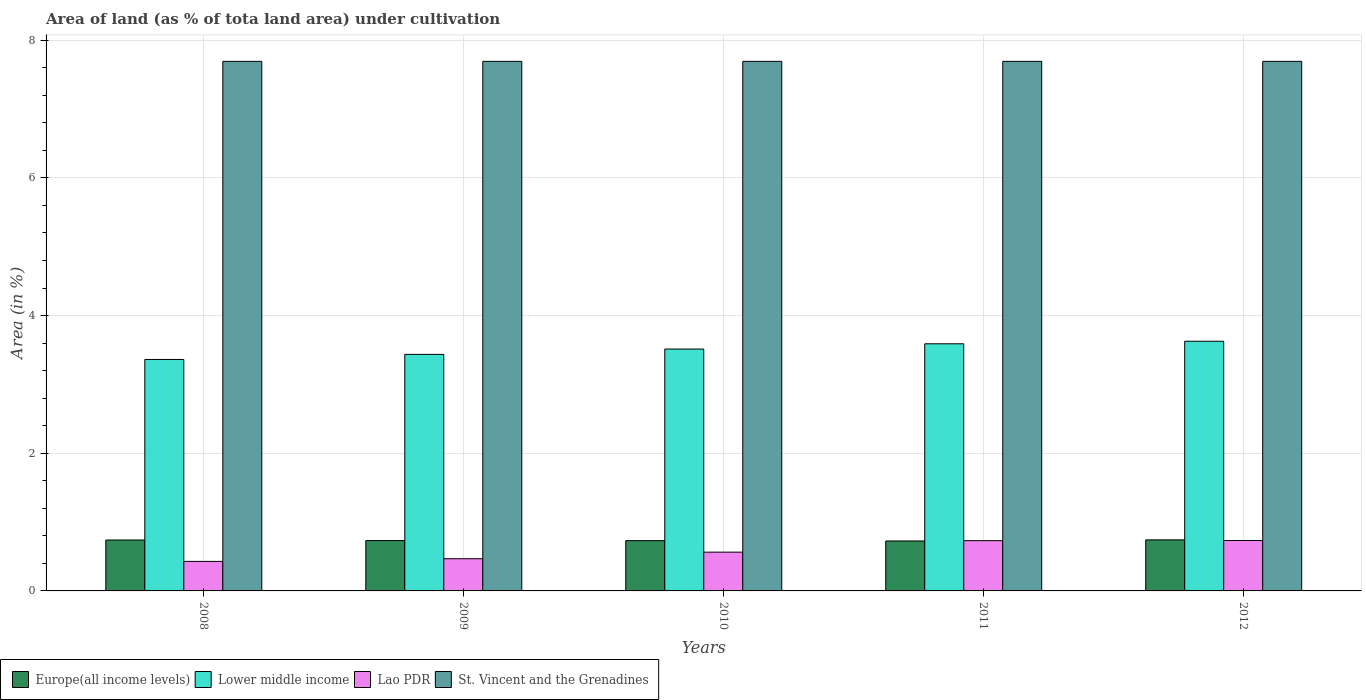How many different coloured bars are there?
Ensure brevity in your answer.  4. Are the number of bars per tick equal to the number of legend labels?
Your response must be concise. Yes. What is the label of the 2nd group of bars from the left?
Provide a short and direct response. 2009. In how many cases, is the number of bars for a given year not equal to the number of legend labels?
Your response must be concise. 0. What is the percentage of land under cultivation in Lower middle income in 2012?
Give a very brief answer. 3.63. Across all years, what is the maximum percentage of land under cultivation in Europe(all income levels)?
Give a very brief answer. 0.74. Across all years, what is the minimum percentage of land under cultivation in Lower middle income?
Provide a succinct answer. 3.36. In which year was the percentage of land under cultivation in Lower middle income minimum?
Offer a terse response. 2008. What is the total percentage of land under cultivation in St. Vincent and the Grenadines in the graph?
Offer a terse response. 38.46. What is the difference between the percentage of land under cultivation in St. Vincent and the Grenadines in 2009 and that in 2010?
Give a very brief answer. 0. What is the difference between the percentage of land under cultivation in Lower middle income in 2011 and the percentage of land under cultivation in St. Vincent and the Grenadines in 2010?
Your response must be concise. -4.1. What is the average percentage of land under cultivation in Lower middle income per year?
Offer a terse response. 3.51. In the year 2012, what is the difference between the percentage of land under cultivation in Lao PDR and percentage of land under cultivation in Lower middle income?
Make the answer very short. -2.89. In how many years, is the percentage of land under cultivation in St. Vincent and the Grenadines greater than 6.4 %?
Ensure brevity in your answer.  5. What is the ratio of the percentage of land under cultivation in Lao PDR in 2008 to that in 2009?
Keep it short and to the point. 0.92. Is the percentage of land under cultivation in St. Vincent and the Grenadines in 2009 less than that in 2012?
Provide a short and direct response. No. What is the difference between the highest and the second highest percentage of land under cultivation in Europe(all income levels)?
Your answer should be compact. 0. What is the difference between the highest and the lowest percentage of land under cultivation in Lower middle income?
Provide a succinct answer. 0.26. Is the sum of the percentage of land under cultivation in Europe(all income levels) in 2008 and 2009 greater than the maximum percentage of land under cultivation in Lower middle income across all years?
Your answer should be very brief. No. What does the 3rd bar from the left in 2008 represents?
Ensure brevity in your answer.  Lao PDR. What does the 1st bar from the right in 2009 represents?
Make the answer very short. St. Vincent and the Grenadines. Is it the case that in every year, the sum of the percentage of land under cultivation in St. Vincent and the Grenadines and percentage of land under cultivation in Lower middle income is greater than the percentage of land under cultivation in Europe(all income levels)?
Your answer should be very brief. Yes. Are all the bars in the graph horizontal?
Make the answer very short. No. What is the difference between two consecutive major ticks on the Y-axis?
Provide a short and direct response. 2. Does the graph contain grids?
Keep it short and to the point. Yes. Where does the legend appear in the graph?
Keep it short and to the point. Bottom left. How many legend labels are there?
Provide a short and direct response. 4. How are the legend labels stacked?
Offer a terse response. Horizontal. What is the title of the graph?
Make the answer very short. Area of land (as % of tota land area) under cultivation. Does "Channel Islands" appear as one of the legend labels in the graph?
Provide a short and direct response. No. What is the label or title of the Y-axis?
Offer a terse response. Area (in %). What is the Area (in %) in Europe(all income levels) in 2008?
Give a very brief answer. 0.74. What is the Area (in %) in Lower middle income in 2008?
Provide a short and direct response. 3.36. What is the Area (in %) in Lao PDR in 2008?
Offer a terse response. 0.43. What is the Area (in %) of St. Vincent and the Grenadines in 2008?
Provide a short and direct response. 7.69. What is the Area (in %) of Europe(all income levels) in 2009?
Keep it short and to the point. 0.73. What is the Area (in %) in Lower middle income in 2009?
Keep it short and to the point. 3.44. What is the Area (in %) of Lao PDR in 2009?
Make the answer very short. 0.47. What is the Area (in %) of St. Vincent and the Grenadines in 2009?
Keep it short and to the point. 7.69. What is the Area (in %) in Europe(all income levels) in 2010?
Offer a very short reply. 0.73. What is the Area (in %) of Lower middle income in 2010?
Your response must be concise. 3.51. What is the Area (in %) of Lao PDR in 2010?
Give a very brief answer. 0.56. What is the Area (in %) in St. Vincent and the Grenadines in 2010?
Ensure brevity in your answer.  7.69. What is the Area (in %) in Europe(all income levels) in 2011?
Offer a terse response. 0.73. What is the Area (in %) of Lower middle income in 2011?
Your answer should be compact. 3.59. What is the Area (in %) in Lao PDR in 2011?
Offer a terse response. 0.73. What is the Area (in %) of St. Vincent and the Grenadines in 2011?
Your answer should be compact. 7.69. What is the Area (in %) in Europe(all income levels) in 2012?
Keep it short and to the point. 0.74. What is the Area (in %) of Lower middle income in 2012?
Keep it short and to the point. 3.63. What is the Area (in %) of Lao PDR in 2012?
Your response must be concise. 0.73. What is the Area (in %) in St. Vincent and the Grenadines in 2012?
Your response must be concise. 7.69. Across all years, what is the maximum Area (in %) in Europe(all income levels)?
Offer a very short reply. 0.74. Across all years, what is the maximum Area (in %) of Lower middle income?
Your response must be concise. 3.63. Across all years, what is the maximum Area (in %) of Lao PDR?
Offer a terse response. 0.73. Across all years, what is the maximum Area (in %) in St. Vincent and the Grenadines?
Give a very brief answer. 7.69. Across all years, what is the minimum Area (in %) in Europe(all income levels)?
Make the answer very short. 0.73. Across all years, what is the minimum Area (in %) of Lower middle income?
Keep it short and to the point. 3.36. Across all years, what is the minimum Area (in %) of Lao PDR?
Offer a terse response. 0.43. Across all years, what is the minimum Area (in %) of St. Vincent and the Grenadines?
Your answer should be compact. 7.69. What is the total Area (in %) in Europe(all income levels) in the graph?
Your response must be concise. 3.67. What is the total Area (in %) in Lower middle income in the graph?
Keep it short and to the point. 17.53. What is the total Area (in %) in Lao PDR in the graph?
Your response must be concise. 2.92. What is the total Area (in %) in St. Vincent and the Grenadines in the graph?
Provide a short and direct response. 38.46. What is the difference between the Area (in %) of Europe(all income levels) in 2008 and that in 2009?
Offer a terse response. 0.01. What is the difference between the Area (in %) in Lower middle income in 2008 and that in 2009?
Give a very brief answer. -0.07. What is the difference between the Area (in %) of Lao PDR in 2008 and that in 2009?
Give a very brief answer. -0.04. What is the difference between the Area (in %) of St. Vincent and the Grenadines in 2008 and that in 2009?
Your answer should be very brief. 0. What is the difference between the Area (in %) in Europe(all income levels) in 2008 and that in 2010?
Your answer should be very brief. 0.01. What is the difference between the Area (in %) in Lower middle income in 2008 and that in 2010?
Your answer should be very brief. -0.15. What is the difference between the Area (in %) in Lao PDR in 2008 and that in 2010?
Your response must be concise. -0.13. What is the difference between the Area (in %) in Europe(all income levels) in 2008 and that in 2011?
Ensure brevity in your answer.  0.01. What is the difference between the Area (in %) of Lower middle income in 2008 and that in 2011?
Give a very brief answer. -0.23. What is the difference between the Area (in %) of Lao PDR in 2008 and that in 2011?
Offer a very short reply. -0.3. What is the difference between the Area (in %) in St. Vincent and the Grenadines in 2008 and that in 2011?
Offer a terse response. 0. What is the difference between the Area (in %) of Europe(all income levels) in 2008 and that in 2012?
Ensure brevity in your answer.  -0. What is the difference between the Area (in %) of Lower middle income in 2008 and that in 2012?
Your response must be concise. -0.26. What is the difference between the Area (in %) of Lao PDR in 2008 and that in 2012?
Offer a very short reply. -0.3. What is the difference between the Area (in %) of Europe(all income levels) in 2009 and that in 2010?
Make the answer very short. 0. What is the difference between the Area (in %) of Lower middle income in 2009 and that in 2010?
Give a very brief answer. -0.08. What is the difference between the Area (in %) of Lao PDR in 2009 and that in 2010?
Offer a terse response. -0.1. What is the difference between the Area (in %) of St. Vincent and the Grenadines in 2009 and that in 2010?
Offer a terse response. 0. What is the difference between the Area (in %) of Europe(all income levels) in 2009 and that in 2011?
Your response must be concise. 0.01. What is the difference between the Area (in %) of Lower middle income in 2009 and that in 2011?
Provide a succinct answer. -0.15. What is the difference between the Area (in %) in Lao PDR in 2009 and that in 2011?
Offer a terse response. -0.26. What is the difference between the Area (in %) in Europe(all income levels) in 2009 and that in 2012?
Your response must be concise. -0.01. What is the difference between the Area (in %) in Lower middle income in 2009 and that in 2012?
Your answer should be very brief. -0.19. What is the difference between the Area (in %) in Lao PDR in 2009 and that in 2012?
Give a very brief answer. -0.26. What is the difference between the Area (in %) in St. Vincent and the Grenadines in 2009 and that in 2012?
Provide a succinct answer. 0. What is the difference between the Area (in %) of Europe(all income levels) in 2010 and that in 2011?
Offer a very short reply. 0. What is the difference between the Area (in %) of Lower middle income in 2010 and that in 2011?
Give a very brief answer. -0.08. What is the difference between the Area (in %) of Lao PDR in 2010 and that in 2011?
Keep it short and to the point. -0.17. What is the difference between the Area (in %) of Europe(all income levels) in 2010 and that in 2012?
Offer a very short reply. -0.01. What is the difference between the Area (in %) in Lower middle income in 2010 and that in 2012?
Keep it short and to the point. -0.11. What is the difference between the Area (in %) of Lao PDR in 2010 and that in 2012?
Your response must be concise. -0.17. What is the difference between the Area (in %) in Europe(all income levels) in 2011 and that in 2012?
Provide a succinct answer. -0.02. What is the difference between the Area (in %) of Lower middle income in 2011 and that in 2012?
Provide a short and direct response. -0.04. What is the difference between the Area (in %) in Lao PDR in 2011 and that in 2012?
Offer a very short reply. -0. What is the difference between the Area (in %) in Europe(all income levels) in 2008 and the Area (in %) in Lower middle income in 2009?
Make the answer very short. -2.7. What is the difference between the Area (in %) in Europe(all income levels) in 2008 and the Area (in %) in Lao PDR in 2009?
Provide a short and direct response. 0.27. What is the difference between the Area (in %) in Europe(all income levels) in 2008 and the Area (in %) in St. Vincent and the Grenadines in 2009?
Provide a succinct answer. -6.95. What is the difference between the Area (in %) of Lower middle income in 2008 and the Area (in %) of Lao PDR in 2009?
Ensure brevity in your answer.  2.89. What is the difference between the Area (in %) of Lower middle income in 2008 and the Area (in %) of St. Vincent and the Grenadines in 2009?
Provide a short and direct response. -4.33. What is the difference between the Area (in %) in Lao PDR in 2008 and the Area (in %) in St. Vincent and the Grenadines in 2009?
Make the answer very short. -7.26. What is the difference between the Area (in %) of Europe(all income levels) in 2008 and the Area (in %) of Lower middle income in 2010?
Your answer should be compact. -2.77. What is the difference between the Area (in %) of Europe(all income levels) in 2008 and the Area (in %) of Lao PDR in 2010?
Offer a terse response. 0.18. What is the difference between the Area (in %) of Europe(all income levels) in 2008 and the Area (in %) of St. Vincent and the Grenadines in 2010?
Your response must be concise. -6.95. What is the difference between the Area (in %) of Lower middle income in 2008 and the Area (in %) of Lao PDR in 2010?
Ensure brevity in your answer.  2.8. What is the difference between the Area (in %) of Lower middle income in 2008 and the Area (in %) of St. Vincent and the Grenadines in 2010?
Your answer should be compact. -4.33. What is the difference between the Area (in %) in Lao PDR in 2008 and the Area (in %) in St. Vincent and the Grenadines in 2010?
Your response must be concise. -7.26. What is the difference between the Area (in %) of Europe(all income levels) in 2008 and the Area (in %) of Lower middle income in 2011?
Make the answer very short. -2.85. What is the difference between the Area (in %) in Europe(all income levels) in 2008 and the Area (in %) in Lao PDR in 2011?
Make the answer very short. 0.01. What is the difference between the Area (in %) in Europe(all income levels) in 2008 and the Area (in %) in St. Vincent and the Grenadines in 2011?
Ensure brevity in your answer.  -6.95. What is the difference between the Area (in %) of Lower middle income in 2008 and the Area (in %) of Lao PDR in 2011?
Your response must be concise. 2.63. What is the difference between the Area (in %) of Lower middle income in 2008 and the Area (in %) of St. Vincent and the Grenadines in 2011?
Offer a very short reply. -4.33. What is the difference between the Area (in %) of Lao PDR in 2008 and the Area (in %) of St. Vincent and the Grenadines in 2011?
Make the answer very short. -7.26. What is the difference between the Area (in %) of Europe(all income levels) in 2008 and the Area (in %) of Lower middle income in 2012?
Your answer should be very brief. -2.89. What is the difference between the Area (in %) of Europe(all income levels) in 2008 and the Area (in %) of Lao PDR in 2012?
Your answer should be compact. 0.01. What is the difference between the Area (in %) in Europe(all income levels) in 2008 and the Area (in %) in St. Vincent and the Grenadines in 2012?
Offer a very short reply. -6.95. What is the difference between the Area (in %) in Lower middle income in 2008 and the Area (in %) in Lao PDR in 2012?
Offer a terse response. 2.63. What is the difference between the Area (in %) of Lower middle income in 2008 and the Area (in %) of St. Vincent and the Grenadines in 2012?
Offer a very short reply. -4.33. What is the difference between the Area (in %) of Lao PDR in 2008 and the Area (in %) of St. Vincent and the Grenadines in 2012?
Offer a terse response. -7.26. What is the difference between the Area (in %) in Europe(all income levels) in 2009 and the Area (in %) in Lower middle income in 2010?
Make the answer very short. -2.78. What is the difference between the Area (in %) in Europe(all income levels) in 2009 and the Area (in %) in Lao PDR in 2010?
Your response must be concise. 0.17. What is the difference between the Area (in %) in Europe(all income levels) in 2009 and the Area (in %) in St. Vincent and the Grenadines in 2010?
Your response must be concise. -6.96. What is the difference between the Area (in %) in Lower middle income in 2009 and the Area (in %) in Lao PDR in 2010?
Make the answer very short. 2.87. What is the difference between the Area (in %) in Lower middle income in 2009 and the Area (in %) in St. Vincent and the Grenadines in 2010?
Make the answer very short. -4.26. What is the difference between the Area (in %) in Lao PDR in 2009 and the Area (in %) in St. Vincent and the Grenadines in 2010?
Ensure brevity in your answer.  -7.22. What is the difference between the Area (in %) of Europe(all income levels) in 2009 and the Area (in %) of Lower middle income in 2011?
Your answer should be very brief. -2.86. What is the difference between the Area (in %) of Europe(all income levels) in 2009 and the Area (in %) of Lao PDR in 2011?
Offer a terse response. 0. What is the difference between the Area (in %) in Europe(all income levels) in 2009 and the Area (in %) in St. Vincent and the Grenadines in 2011?
Your answer should be very brief. -6.96. What is the difference between the Area (in %) of Lower middle income in 2009 and the Area (in %) of Lao PDR in 2011?
Make the answer very short. 2.71. What is the difference between the Area (in %) in Lower middle income in 2009 and the Area (in %) in St. Vincent and the Grenadines in 2011?
Provide a succinct answer. -4.26. What is the difference between the Area (in %) of Lao PDR in 2009 and the Area (in %) of St. Vincent and the Grenadines in 2011?
Ensure brevity in your answer.  -7.22. What is the difference between the Area (in %) in Europe(all income levels) in 2009 and the Area (in %) in Lower middle income in 2012?
Your response must be concise. -2.9. What is the difference between the Area (in %) of Europe(all income levels) in 2009 and the Area (in %) of Lao PDR in 2012?
Offer a terse response. -0. What is the difference between the Area (in %) of Europe(all income levels) in 2009 and the Area (in %) of St. Vincent and the Grenadines in 2012?
Your response must be concise. -6.96. What is the difference between the Area (in %) in Lower middle income in 2009 and the Area (in %) in Lao PDR in 2012?
Offer a very short reply. 2.7. What is the difference between the Area (in %) of Lower middle income in 2009 and the Area (in %) of St. Vincent and the Grenadines in 2012?
Your answer should be compact. -4.26. What is the difference between the Area (in %) of Lao PDR in 2009 and the Area (in %) of St. Vincent and the Grenadines in 2012?
Offer a very short reply. -7.22. What is the difference between the Area (in %) of Europe(all income levels) in 2010 and the Area (in %) of Lower middle income in 2011?
Offer a terse response. -2.86. What is the difference between the Area (in %) in Europe(all income levels) in 2010 and the Area (in %) in Lao PDR in 2011?
Give a very brief answer. 0. What is the difference between the Area (in %) in Europe(all income levels) in 2010 and the Area (in %) in St. Vincent and the Grenadines in 2011?
Give a very brief answer. -6.96. What is the difference between the Area (in %) in Lower middle income in 2010 and the Area (in %) in Lao PDR in 2011?
Give a very brief answer. 2.78. What is the difference between the Area (in %) in Lower middle income in 2010 and the Area (in %) in St. Vincent and the Grenadines in 2011?
Provide a succinct answer. -4.18. What is the difference between the Area (in %) in Lao PDR in 2010 and the Area (in %) in St. Vincent and the Grenadines in 2011?
Your answer should be compact. -7.13. What is the difference between the Area (in %) in Europe(all income levels) in 2010 and the Area (in %) in Lower middle income in 2012?
Make the answer very short. -2.9. What is the difference between the Area (in %) of Europe(all income levels) in 2010 and the Area (in %) of Lao PDR in 2012?
Offer a terse response. -0. What is the difference between the Area (in %) of Europe(all income levels) in 2010 and the Area (in %) of St. Vincent and the Grenadines in 2012?
Keep it short and to the point. -6.96. What is the difference between the Area (in %) of Lower middle income in 2010 and the Area (in %) of Lao PDR in 2012?
Offer a terse response. 2.78. What is the difference between the Area (in %) of Lower middle income in 2010 and the Area (in %) of St. Vincent and the Grenadines in 2012?
Your answer should be very brief. -4.18. What is the difference between the Area (in %) in Lao PDR in 2010 and the Area (in %) in St. Vincent and the Grenadines in 2012?
Give a very brief answer. -7.13. What is the difference between the Area (in %) of Europe(all income levels) in 2011 and the Area (in %) of Lower middle income in 2012?
Provide a short and direct response. -2.9. What is the difference between the Area (in %) of Europe(all income levels) in 2011 and the Area (in %) of Lao PDR in 2012?
Offer a very short reply. -0.01. What is the difference between the Area (in %) in Europe(all income levels) in 2011 and the Area (in %) in St. Vincent and the Grenadines in 2012?
Keep it short and to the point. -6.97. What is the difference between the Area (in %) of Lower middle income in 2011 and the Area (in %) of Lao PDR in 2012?
Ensure brevity in your answer.  2.86. What is the difference between the Area (in %) in Lower middle income in 2011 and the Area (in %) in St. Vincent and the Grenadines in 2012?
Your answer should be compact. -4.1. What is the difference between the Area (in %) of Lao PDR in 2011 and the Area (in %) of St. Vincent and the Grenadines in 2012?
Your answer should be very brief. -6.96. What is the average Area (in %) in Europe(all income levels) per year?
Provide a succinct answer. 0.73. What is the average Area (in %) of Lower middle income per year?
Give a very brief answer. 3.51. What is the average Area (in %) of Lao PDR per year?
Your answer should be compact. 0.58. What is the average Area (in %) in St. Vincent and the Grenadines per year?
Offer a terse response. 7.69. In the year 2008, what is the difference between the Area (in %) of Europe(all income levels) and Area (in %) of Lower middle income?
Your response must be concise. -2.62. In the year 2008, what is the difference between the Area (in %) in Europe(all income levels) and Area (in %) in Lao PDR?
Your answer should be very brief. 0.31. In the year 2008, what is the difference between the Area (in %) of Europe(all income levels) and Area (in %) of St. Vincent and the Grenadines?
Keep it short and to the point. -6.95. In the year 2008, what is the difference between the Area (in %) of Lower middle income and Area (in %) of Lao PDR?
Your response must be concise. 2.93. In the year 2008, what is the difference between the Area (in %) of Lower middle income and Area (in %) of St. Vincent and the Grenadines?
Provide a succinct answer. -4.33. In the year 2008, what is the difference between the Area (in %) of Lao PDR and Area (in %) of St. Vincent and the Grenadines?
Your answer should be compact. -7.26. In the year 2009, what is the difference between the Area (in %) of Europe(all income levels) and Area (in %) of Lower middle income?
Your response must be concise. -2.7. In the year 2009, what is the difference between the Area (in %) of Europe(all income levels) and Area (in %) of Lao PDR?
Offer a terse response. 0.26. In the year 2009, what is the difference between the Area (in %) of Europe(all income levels) and Area (in %) of St. Vincent and the Grenadines?
Make the answer very short. -6.96. In the year 2009, what is the difference between the Area (in %) of Lower middle income and Area (in %) of Lao PDR?
Offer a very short reply. 2.97. In the year 2009, what is the difference between the Area (in %) in Lower middle income and Area (in %) in St. Vincent and the Grenadines?
Offer a very short reply. -4.26. In the year 2009, what is the difference between the Area (in %) of Lao PDR and Area (in %) of St. Vincent and the Grenadines?
Offer a terse response. -7.22. In the year 2010, what is the difference between the Area (in %) in Europe(all income levels) and Area (in %) in Lower middle income?
Offer a very short reply. -2.78. In the year 2010, what is the difference between the Area (in %) in Europe(all income levels) and Area (in %) in Lao PDR?
Give a very brief answer. 0.17. In the year 2010, what is the difference between the Area (in %) of Europe(all income levels) and Area (in %) of St. Vincent and the Grenadines?
Provide a short and direct response. -6.96. In the year 2010, what is the difference between the Area (in %) in Lower middle income and Area (in %) in Lao PDR?
Make the answer very short. 2.95. In the year 2010, what is the difference between the Area (in %) in Lower middle income and Area (in %) in St. Vincent and the Grenadines?
Keep it short and to the point. -4.18. In the year 2010, what is the difference between the Area (in %) of Lao PDR and Area (in %) of St. Vincent and the Grenadines?
Provide a short and direct response. -7.13. In the year 2011, what is the difference between the Area (in %) in Europe(all income levels) and Area (in %) in Lower middle income?
Make the answer very short. -2.86. In the year 2011, what is the difference between the Area (in %) of Europe(all income levels) and Area (in %) of Lao PDR?
Your response must be concise. -0. In the year 2011, what is the difference between the Area (in %) of Europe(all income levels) and Area (in %) of St. Vincent and the Grenadines?
Ensure brevity in your answer.  -6.97. In the year 2011, what is the difference between the Area (in %) in Lower middle income and Area (in %) in Lao PDR?
Offer a very short reply. 2.86. In the year 2011, what is the difference between the Area (in %) of Lower middle income and Area (in %) of St. Vincent and the Grenadines?
Give a very brief answer. -4.1. In the year 2011, what is the difference between the Area (in %) of Lao PDR and Area (in %) of St. Vincent and the Grenadines?
Give a very brief answer. -6.96. In the year 2012, what is the difference between the Area (in %) in Europe(all income levels) and Area (in %) in Lower middle income?
Your answer should be compact. -2.89. In the year 2012, what is the difference between the Area (in %) of Europe(all income levels) and Area (in %) of Lao PDR?
Provide a short and direct response. 0.01. In the year 2012, what is the difference between the Area (in %) in Europe(all income levels) and Area (in %) in St. Vincent and the Grenadines?
Your response must be concise. -6.95. In the year 2012, what is the difference between the Area (in %) in Lower middle income and Area (in %) in Lao PDR?
Offer a terse response. 2.89. In the year 2012, what is the difference between the Area (in %) in Lower middle income and Area (in %) in St. Vincent and the Grenadines?
Ensure brevity in your answer.  -4.07. In the year 2012, what is the difference between the Area (in %) of Lao PDR and Area (in %) of St. Vincent and the Grenadines?
Make the answer very short. -6.96. What is the ratio of the Area (in %) of Europe(all income levels) in 2008 to that in 2009?
Give a very brief answer. 1.01. What is the ratio of the Area (in %) of Lower middle income in 2008 to that in 2009?
Keep it short and to the point. 0.98. What is the ratio of the Area (in %) of Europe(all income levels) in 2008 to that in 2010?
Your response must be concise. 1.01. What is the ratio of the Area (in %) in Lower middle income in 2008 to that in 2010?
Your answer should be very brief. 0.96. What is the ratio of the Area (in %) of Lao PDR in 2008 to that in 2010?
Provide a succinct answer. 0.76. What is the ratio of the Area (in %) in St. Vincent and the Grenadines in 2008 to that in 2010?
Your response must be concise. 1. What is the ratio of the Area (in %) of Europe(all income levels) in 2008 to that in 2011?
Provide a short and direct response. 1.02. What is the ratio of the Area (in %) in Lower middle income in 2008 to that in 2011?
Your response must be concise. 0.94. What is the ratio of the Area (in %) of Lao PDR in 2008 to that in 2011?
Provide a succinct answer. 0.59. What is the ratio of the Area (in %) of St. Vincent and the Grenadines in 2008 to that in 2011?
Offer a very short reply. 1. What is the ratio of the Area (in %) of Europe(all income levels) in 2008 to that in 2012?
Ensure brevity in your answer.  1. What is the ratio of the Area (in %) of Lower middle income in 2008 to that in 2012?
Your answer should be compact. 0.93. What is the ratio of the Area (in %) in Lao PDR in 2008 to that in 2012?
Provide a succinct answer. 0.59. What is the ratio of the Area (in %) in Lower middle income in 2009 to that in 2010?
Keep it short and to the point. 0.98. What is the ratio of the Area (in %) in Lao PDR in 2009 to that in 2010?
Your answer should be compact. 0.83. What is the ratio of the Area (in %) of St. Vincent and the Grenadines in 2009 to that in 2010?
Give a very brief answer. 1. What is the ratio of the Area (in %) in Europe(all income levels) in 2009 to that in 2011?
Your answer should be compact. 1.01. What is the ratio of the Area (in %) of Lower middle income in 2009 to that in 2011?
Give a very brief answer. 0.96. What is the ratio of the Area (in %) in Lao PDR in 2009 to that in 2011?
Your answer should be very brief. 0.64. What is the ratio of the Area (in %) in Europe(all income levels) in 2009 to that in 2012?
Your answer should be compact. 0.99. What is the ratio of the Area (in %) in Lao PDR in 2009 to that in 2012?
Provide a short and direct response. 0.64. What is the ratio of the Area (in %) of St. Vincent and the Grenadines in 2009 to that in 2012?
Your answer should be compact. 1. What is the ratio of the Area (in %) of Europe(all income levels) in 2010 to that in 2011?
Make the answer very short. 1.01. What is the ratio of the Area (in %) in Lower middle income in 2010 to that in 2011?
Make the answer very short. 0.98. What is the ratio of the Area (in %) of Lao PDR in 2010 to that in 2011?
Keep it short and to the point. 0.77. What is the ratio of the Area (in %) of St. Vincent and the Grenadines in 2010 to that in 2011?
Provide a succinct answer. 1. What is the ratio of the Area (in %) in Europe(all income levels) in 2010 to that in 2012?
Offer a very short reply. 0.98. What is the ratio of the Area (in %) in Lower middle income in 2010 to that in 2012?
Make the answer very short. 0.97. What is the ratio of the Area (in %) in Lao PDR in 2010 to that in 2012?
Keep it short and to the point. 0.77. What is the ratio of the Area (in %) of Europe(all income levels) in 2011 to that in 2012?
Offer a terse response. 0.98. What is the ratio of the Area (in %) of Lower middle income in 2011 to that in 2012?
Your answer should be very brief. 0.99. What is the ratio of the Area (in %) in Lao PDR in 2011 to that in 2012?
Give a very brief answer. 1. What is the difference between the highest and the second highest Area (in %) of Europe(all income levels)?
Offer a very short reply. 0. What is the difference between the highest and the second highest Area (in %) of Lower middle income?
Keep it short and to the point. 0.04. What is the difference between the highest and the second highest Area (in %) of Lao PDR?
Your answer should be very brief. 0. What is the difference between the highest and the second highest Area (in %) in St. Vincent and the Grenadines?
Your answer should be compact. 0. What is the difference between the highest and the lowest Area (in %) of Europe(all income levels)?
Provide a short and direct response. 0.02. What is the difference between the highest and the lowest Area (in %) in Lower middle income?
Offer a terse response. 0.26. What is the difference between the highest and the lowest Area (in %) of Lao PDR?
Offer a terse response. 0.3. 